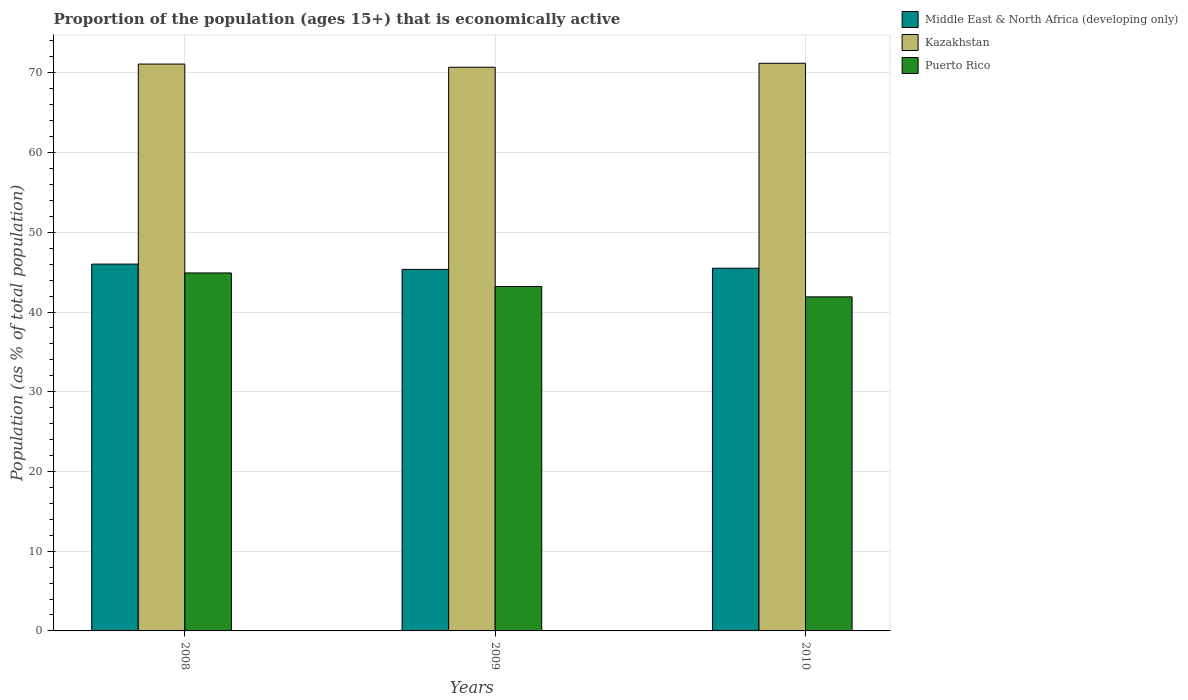How many different coloured bars are there?
Your answer should be very brief. 3. Are the number of bars per tick equal to the number of legend labels?
Give a very brief answer. Yes. How many bars are there on the 3rd tick from the left?
Provide a short and direct response. 3. In how many cases, is the number of bars for a given year not equal to the number of legend labels?
Provide a short and direct response. 0. What is the proportion of the population that is economically active in Kazakhstan in 2008?
Give a very brief answer. 71.1. Across all years, what is the maximum proportion of the population that is economically active in Puerto Rico?
Give a very brief answer. 44.9. Across all years, what is the minimum proportion of the population that is economically active in Kazakhstan?
Offer a very short reply. 70.7. What is the total proportion of the population that is economically active in Middle East & North Africa (developing only) in the graph?
Ensure brevity in your answer.  136.84. What is the difference between the proportion of the population that is economically active in Kazakhstan in 2008 and that in 2010?
Ensure brevity in your answer.  -0.1. What is the difference between the proportion of the population that is economically active in Kazakhstan in 2010 and the proportion of the population that is economically active in Puerto Rico in 2009?
Keep it short and to the point. 28. What is the average proportion of the population that is economically active in Kazakhstan per year?
Provide a short and direct response. 71. In the year 2010, what is the difference between the proportion of the population that is economically active in Puerto Rico and proportion of the population that is economically active in Kazakhstan?
Your response must be concise. -29.3. What is the ratio of the proportion of the population that is economically active in Middle East & North Africa (developing only) in 2008 to that in 2009?
Provide a succinct answer. 1.01. What is the difference between the highest and the second highest proportion of the population that is economically active in Puerto Rico?
Your answer should be compact. 1.7. In how many years, is the proportion of the population that is economically active in Puerto Rico greater than the average proportion of the population that is economically active in Puerto Rico taken over all years?
Give a very brief answer. 1. Is the sum of the proportion of the population that is economically active in Puerto Rico in 2008 and 2009 greater than the maximum proportion of the population that is economically active in Middle East & North Africa (developing only) across all years?
Your answer should be very brief. Yes. What does the 2nd bar from the left in 2009 represents?
Give a very brief answer. Kazakhstan. What does the 2nd bar from the right in 2009 represents?
Give a very brief answer. Kazakhstan. Is it the case that in every year, the sum of the proportion of the population that is economically active in Puerto Rico and proportion of the population that is economically active in Middle East & North Africa (developing only) is greater than the proportion of the population that is economically active in Kazakhstan?
Provide a short and direct response. Yes. Are all the bars in the graph horizontal?
Provide a succinct answer. No. Does the graph contain any zero values?
Your answer should be compact. No. How many legend labels are there?
Give a very brief answer. 3. What is the title of the graph?
Your answer should be very brief. Proportion of the population (ages 15+) that is economically active. What is the label or title of the Y-axis?
Keep it short and to the point. Population (as % of total population). What is the Population (as % of total population) of Middle East & North Africa (developing only) in 2008?
Ensure brevity in your answer.  46.01. What is the Population (as % of total population) in Kazakhstan in 2008?
Keep it short and to the point. 71.1. What is the Population (as % of total population) in Puerto Rico in 2008?
Offer a terse response. 44.9. What is the Population (as % of total population) of Middle East & North Africa (developing only) in 2009?
Your answer should be compact. 45.34. What is the Population (as % of total population) in Kazakhstan in 2009?
Make the answer very short. 70.7. What is the Population (as % of total population) of Puerto Rico in 2009?
Keep it short and to the point. 43.2. What is the Population (as % of total population) of Middle East & North Africa (developing only) in 2010?
Your answer should be very brief. 45.49. What is the Population (as % of total population) in Kazakhstan in 2010?
Provide a short and direct response. 71.2. What is the Population (as % of total population) in Puerto Rico in 2010?
Offer a terse response. 41.9. Across all years, what is the maximum Population (as % of total population) of Middle East & North Africa (developing only)?
Offer a very short reply. 46.01. Across all years, what is the maximum Population (as % of total population) in Kazakhstan?
Give a very brief answer. 71.2. Across all years, what is the maximum Population (as % of total population) of Puerto Rico?
Your answer should be compact. 44.9. Across all years, what is the minimum Population (as % of total population) of Middle East & North Africa (developing only)?
Ensure brevity in your answer.  45.34. Across all years, what is the minimum Population (as % of total population) in Kazakhstan?
Your answer should be very brief. 70.7. Across all years, what is the minimum Population (as % of total population) of Puerto Rico?
Your response must be concise. 41.9. What is the total Population (as % of total population) of Middle East & North Africa (developing only) in the graph?
Provide a short and direct response. 136.84. What is the total Population (as % of total population) in Kazakhstan in the graph?
Provide a short and direct response. 213. What is the total Population (as % of total population) of Puerto Rico in the graph?
Your response must be concise. 130. What is the difference between the Population (as % of total population) of Middle East & North Africa (developing only) in 2008 and that in 2009?
Provide a short and direct response. 0.66. What is the difference between the Population (as % of total population) of Kazakhstan in 2008 and that in 2009?
Offer a very short reply. 0.4. What is the difference between the Population (as % of total population) of Middle East & North Africa (developing only) in 2008 and that in 2010?
Offer a very short reply. 0.52. What is the difference between the Population (as % of total population) in Puerto Rico in 2008 and that in 2010?
Offer a terse response. 3. What is the difference between the Population (as % of total population) of Middle East & North Africa (developing only) in 2009 and that in 2010?
Ensure brevity in your answer.  -0.15. What is the difference between the Population (as % of total population) of Middle East & North Africa (developing only) in 2008 and the Population (as % of total population) of Kazakhstan in 2009?
Keep it short and to the point. -24.69. What is the difference between the Population (as % of total population) in Middle East & North Africa (developing only) in 2008 and the Population (as % of total population) in Puerto Rico in 2009?
Keep it short and to the point. 2.81. What is the difference between the Population (as % of total population) of Kazakhstan in 2008 and the Population (as % of total population) of Puerto Rico in 2009?
Give a very brief answer. 27.9. What is the difference between the Population (as % of total population) in Middle East & North Africa (developing only) in 2008 and the Population (as % of total population) in Kazakhstan in 2010?
Your answer should be very brief. -25.19. What is the difference between the Population (as % of total population) of Middle East & North Africa (developing only) in 2008 and the Population (as % of total population) of Puerto Rico in 2010?
Provide a short and direct response. 4.11. What is the difference between the Population (as % of total population) of Kazakhstan in 2008 and the Population (as % of total population) of Puerto Rico in 2010?
Keep it short and to the point. 29.2. What is the difference between the Population (as % of total population) of Middle East & North Africa (developing only) in 2009 and the Population (as % of total population) of Kazakhstan in 2010?
Keep it short and to the point. -25.86. What is the difference between the Population (as % of total population) in Middle East & North Africa (developing only) in 2009 and the Population (as % of total population) in Puerto Rico in 2010?
Ensure brevity in your answer.  3.44. What is the difference between the Population (as % of total population) of Kazakhstan in 2009 and the Population (as % of total population) of Puerto Rico in 2010?
Make the answer very short. 28.8. What is the average Population (as % of total population) of Middle East & North Africa (developing only) per year?
Your answer should be compact. 45.61. What is the average Population (as % of total population) in Kazakhstan per year?
Ensure brevity in your answer.  71. What is the average Population (as % of total population) of Puerto Rico per year?
Offer a very short reply. 43.33. In the year 2008, what is the difference between the Population (as % of total population) of Middle East & North Africa (developing only) and Population (as % of total population) of Kazakhstan?
Provide a succinct answer. -25.09. In the year 2008, what is the difference between the Population (as % of total population) in Middle East & North Africa (developing only) and Population (as % of total population) in Puerto Rico?
Your answer should be compact. 1.11. In the year 2008, what is the difference between the Population (as % of total population) of Kazakhstan and Population (as % of total population) of Puerto Rico?
Ensure brevity in your answer.  26.2. In the year 2009, what is the difference between the Population (as % of total population) in Middle East & North Africa (developing only) and Population (as % of total population) in Kazakhstan?
Provide a succinct answer. -25.36. In the year 2009, what is the difference between the Population (as % of total population) in Middle East & North Africa (developing only) and Population (as % of total population) in Puerto Rico?
Your answer should be compact. 2.14. In the year 2009, what is the difference between the Population (as % of total population) of Kazakhstan and Population (as % of total population) of Puerto Rico?
Keep it short and to the point. 27.5. In the year 2010, what is the difference between the Population (as % of total population) in Middle East & North Africa (developing only) and Population (as % of total population) in Kazakhstan?
Provide a short and direct response. -25.71. In the year 2010, what is the difference between the Population (as % of total population) of Middle East & North Africa (developing only) and Population (as % of total population) of Puerto Rico?
Your answer should be compact. 3.59. In the year 2010, what is the difference between the Population (as % of total population) of Kazakhstan and Population (as % of total population) of Puerto Rico?
Keep it short and to the point. 29.3. What is the ratio of the Population (as % of total population) of Middle East & North Africa (developing only) in 2008 to that in 2009?
Your answer should be compact. 1.01. What is the ratio of the Population (as % of total population) of Puerto Rico in 2008 to that in 2009?
Make the answer very short. 1.04. What is the ratio of the Population (as % of total population) of Middle East & North Africa (developing only) in 2008 to that in 2010?
Keep it short and to the point. 1.01. What is the ratio of the Population (as % of total population) in Kazakhstan in 2008 to that in 2010?
Offer a very short reply. 1. What is the ratio of the Population (as % of total population) of Puerto Rico in 2008 to that in 2010?
Provide a succinct answer. 1.07. What is the ratio of the Population (as % of total population) of Kazakhstan in 2009 to that in 2010?
Your response must be concise. 0.99. What is the ratio of the Population (as % of total population) of Puerto Rico in 2009 to that in 2010?
Offer a terse response. 1.03. What is the difference between the highest and the second highest Population (as % of total population) in Middle East & North Africa (developing only)?
Offer a terse response. 0.52. What is the difference between the highest and the second highest Population (as % of total population) of Kazakhstan?
Offer a very short reply. 0.1. What is the difference between the highest and the second highest Population (as % of total population) of Puerto Rico?
Your answer should be very brief. 1.7. What is the difference between the highest and the lowest Population (as % of total population) of Middle East & North Africa (developing only)?
Make the answer very short. 0.66. What is the difference between the highest and the lowest Population (as % of total population) in Puerto Rico?
Your response must be concise. 3. 